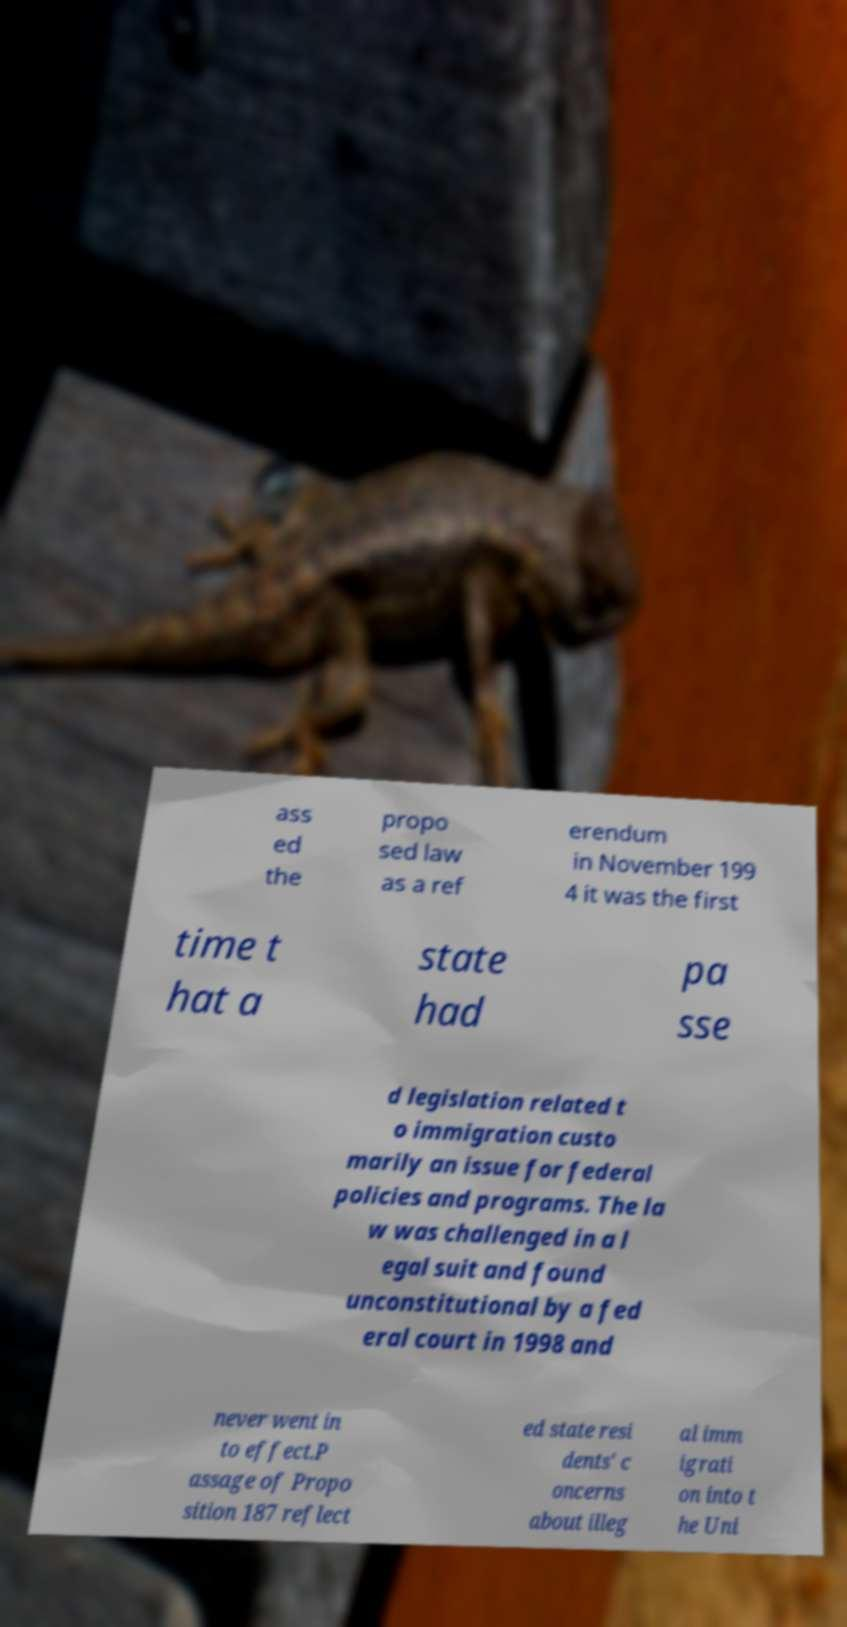What messages or text are displayed in this image? I need them in a readable, typed format. ass ed the propo sed law as a ref erendum in November 199 4 it was the first time t hat a state had pa sse d legislation related t o immigration custo marily an issue for federal policies and programs. The la w was challenged in a l egal suit and found unconstitutional by a fed eral court in 1998 and never went in to effect.P assage of Propo sition 187 reflect ed state resi dents' c oncerns about illeg al imm igrati on into t he Uni 